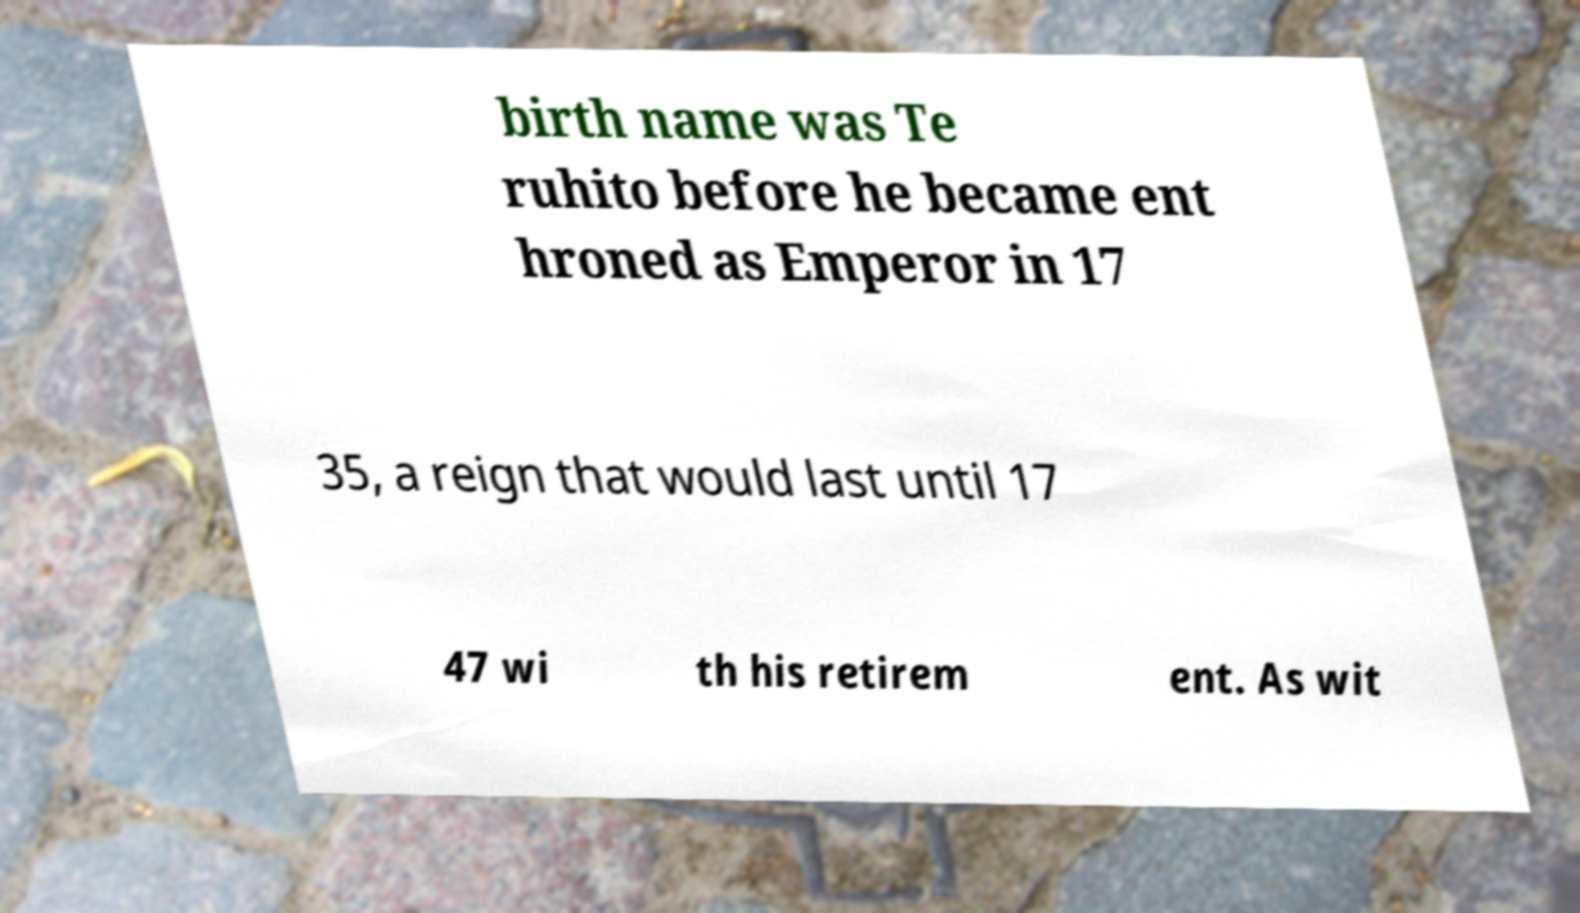What messages or text are displayed in this image? I need them in a readable, typed format. birth name was Te ruhito before he became ent hroned as Emperor in 17 35, a reign that would last until 17 47 wi th his retirem ent. As wit 